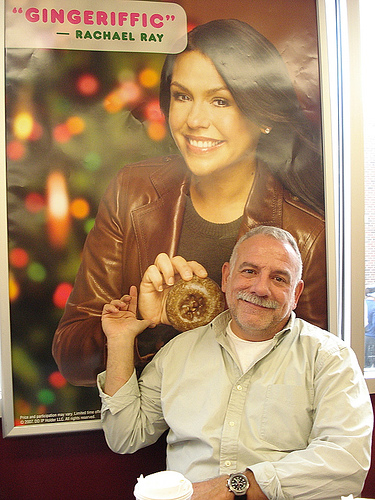<image>What food is on top of the donut? I am not sure what is on top of the donut. It could be chocolate, ginger, glaze, peanuts, or icing. What food is on top of the donut? I am not sure what food is on top of the donut. It can be either chocolate, ginger, glaze or peanuts. 